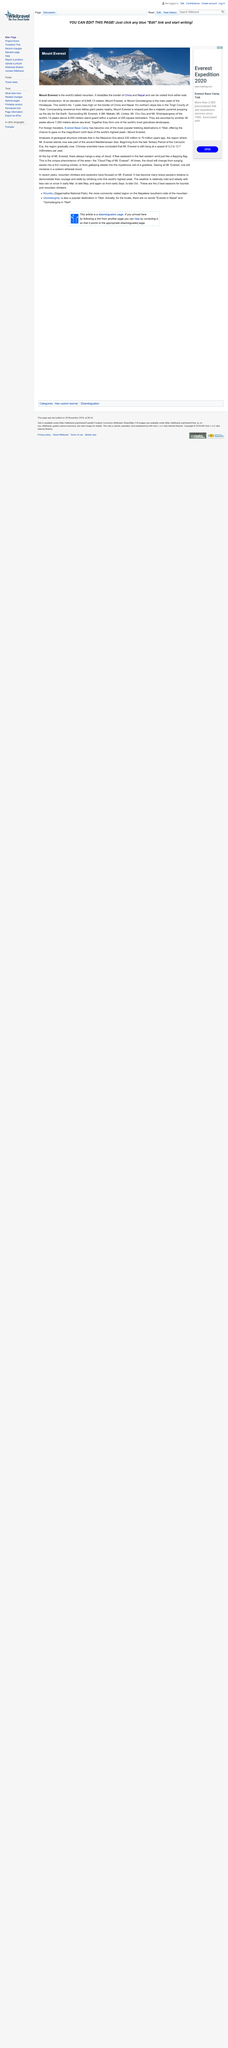Draw attention to some important aspects in this diagram. The world's tallest mountain is Mount Everest. One of the most popular trekking destinations in Tibet is Everest Base Camp, which attracts countless adventure-seekers each year with its breathtaking views of the world's highest mountain. Mount Everest, the world's highest mountain, is located on the border between China and Nepal. It is a significant landmark and a popular destination for mountaineers and adventure seekers. 